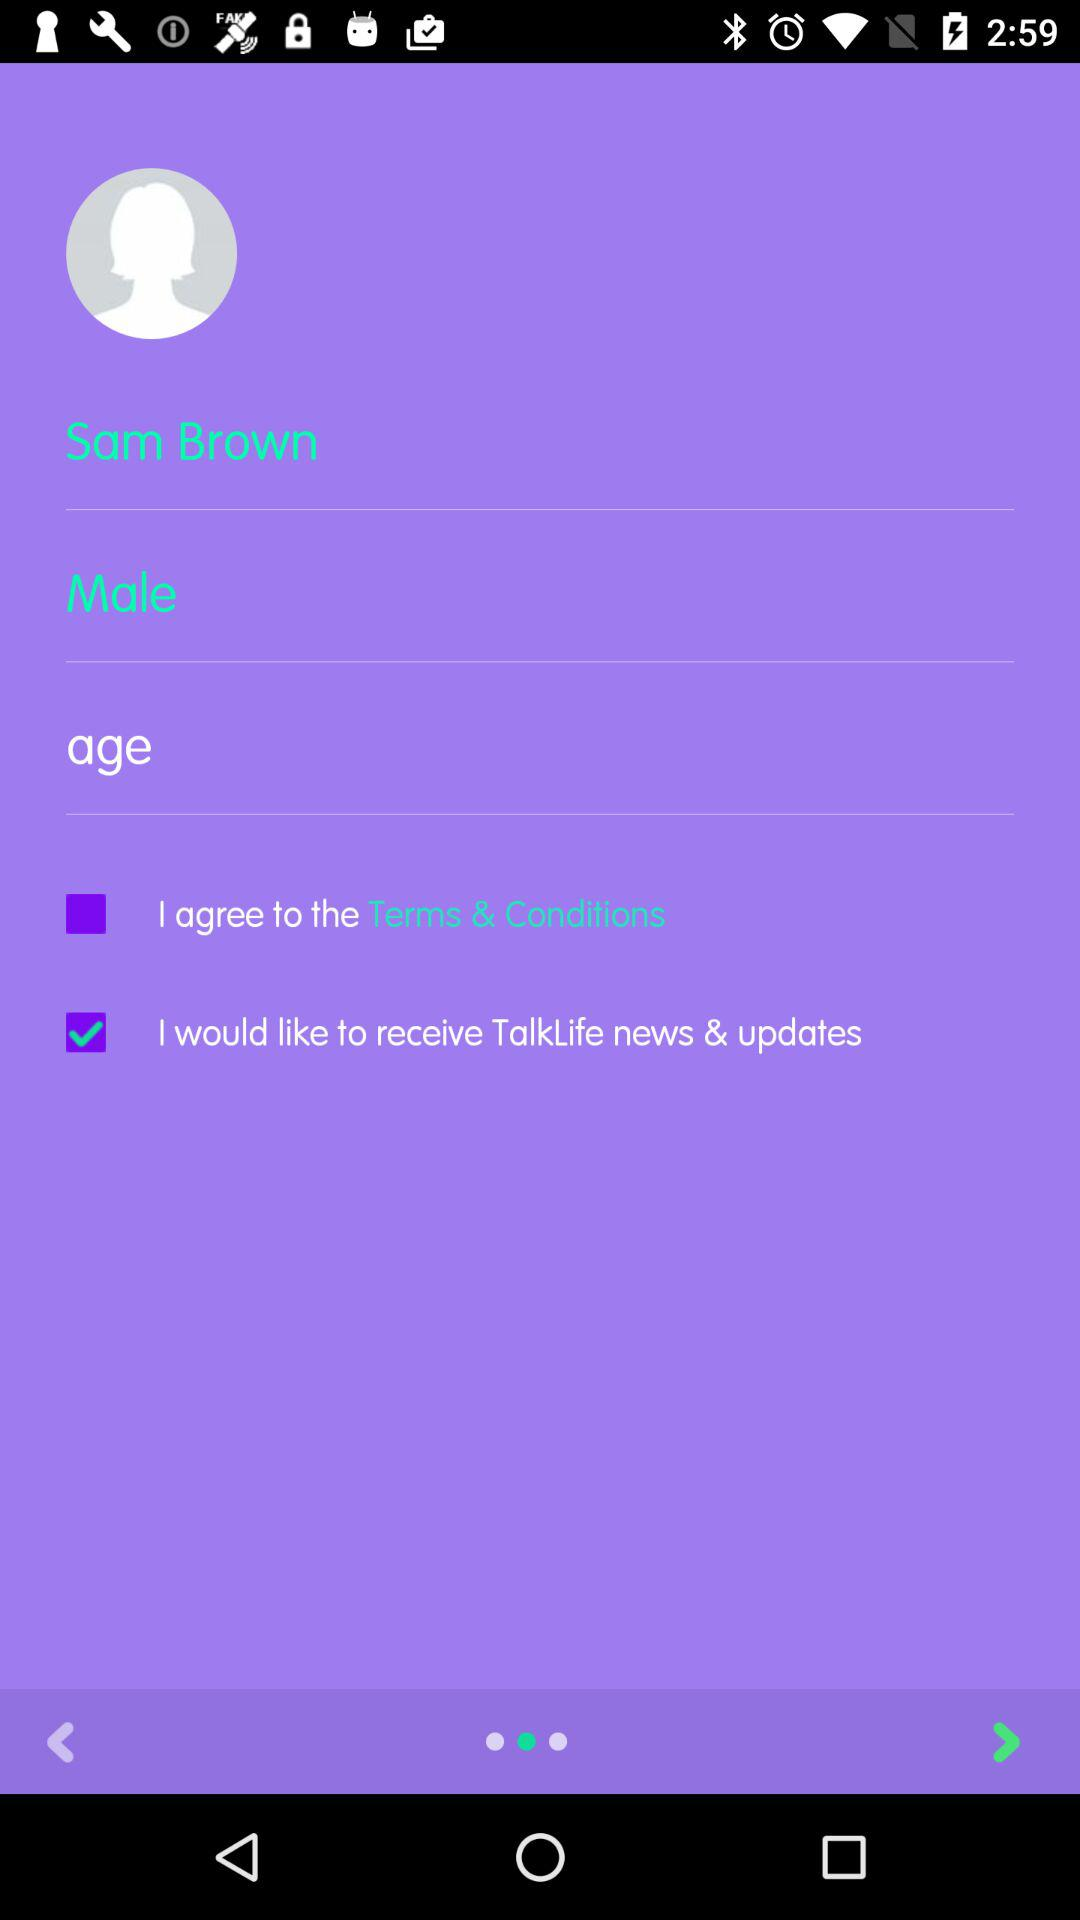How old is Sam Brown?
When the provided information is insufficient, respond with <no answer>. <no answer> 